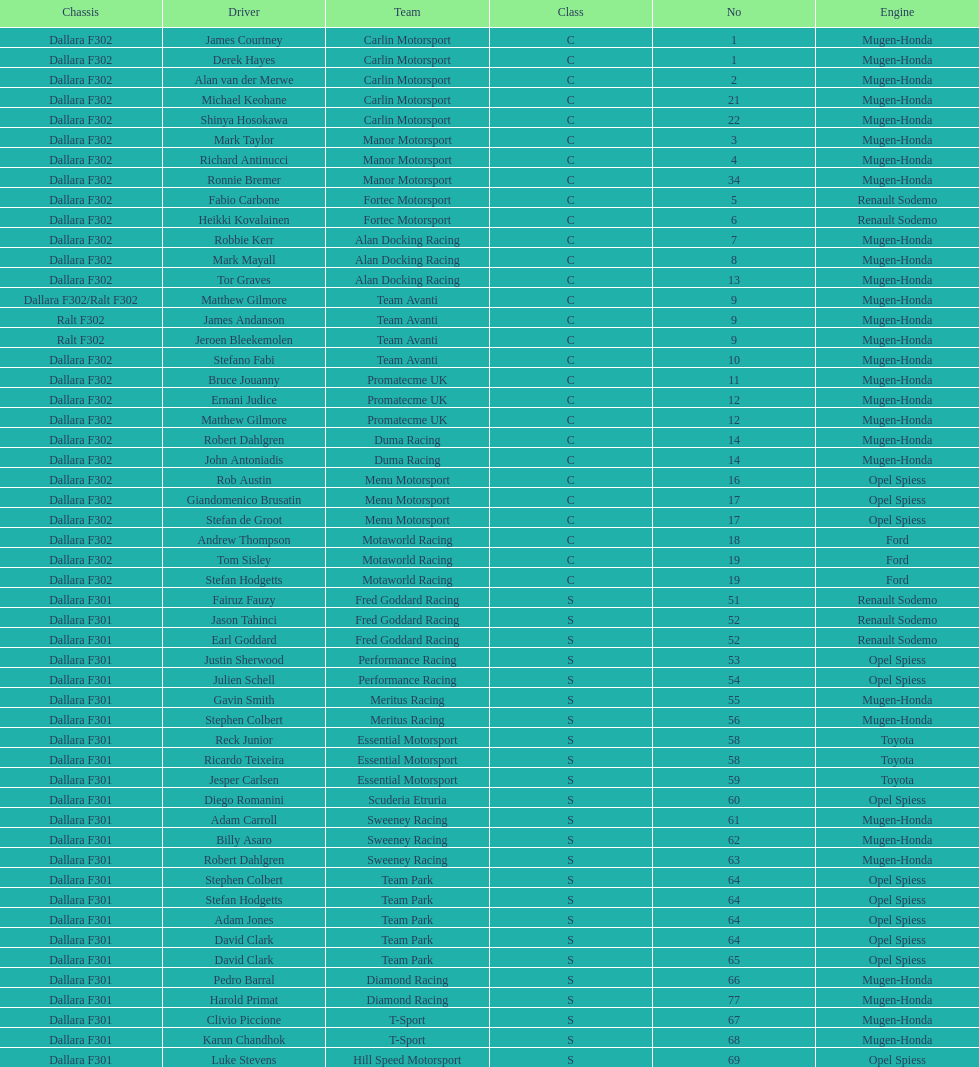How many teams had at least two drivers this season? 17. Give me the full table as a dictionary. {'header': ['Chassis', 'Driver', 'Team', 'Class', 'No', 'Engine'], 'rows': [['Dallara F302', 'James Courtney', 'Carlin Motorsport', 'C', '1', 'Mugen-Honda'], ['Dallara F302', 'Derek Hayes', 'Carlin Motorsport', 'C', '1', 'Mugen-Honda'], ['Dallara F302', 'Alan van der Merwe', 'Carlin Motorsport', 'C', '2', 'Mugen-Honda'], ['Dallara F302', 'Michael Keohane', 'Carlin Motorsport', 'C', '21', 'Mugen-Honda'], ['Dallara F302', 'Shinya Hosokawa', 'Carlin Motorsport', 'C', '22', 'Mugen-Honda'], ['Dallara F302', 'Mark Taylor', 'Manor Motorsport', 'C', '3', 'Mugen-Honda'], ['Dallara F302', 'Richard Antinucci', 'Manor Motorsport', 'C', '4', 'Mugen-Honda'], ['Dallara F302', 'Ronnie Bremer', 'Manor Motorsport', 'C', '34', 'Mugen-Honda'], ['Dallara F302', 'Fabio Carbone', 'Fortec Motorsport', 'C', '5', 'Renault Sodemo'], ['Dallara F302', 'Heikki Kovalainen', 'Fortec Motorsport', 'C', '6', 'Renault Sodemo'], ['Dallara F302', 'Robbie Kerr', 'Alan Docking Racing', 'C', '7', 'Mugen-Honda'], ['Dallara F302', 'Mark Mayall', 'Alan Docking Racing', 'C', '8', 'Mugen-Honda'], ['Dallara F302', 'Tor Graves', 'Alan Docking Racing', 'C', '13', 'Mugen-Honda'], ['Dallara F302/Ralt F302', 'Matthew Gilmore', 'Team Avanti', 'C', '9', 'Mugen-Honda'], ['Ralt F302', 'James Andanson', 'Team Avanti', 'C', '9', 'Mugen-Honda'], ['Ralt F302', 'Jeroen Bleekemolen', 'Team Avanti', 'C', '9', 'Mugen-Honda'], ['Dallara F302', 'Stefano Fabi', 'Team Avanti', 'C', '10', 'Mugen-Honda'], ['Dallara F302', 'Bruce Jouanny', 'Promatecme UK', 'C', '11', 'Mugen-Honda'], ['Dallara F302', 'Ernani Judice', 'Promatecme UK', 'C', '12', 'Mugen-Honda'], ['Dallara F302', 'Matthew Gilmore', 'Promatecme UK', 'C', '12', 'Mugen-Honda'], ['Dallara F302', 'Robert Dahlgren', 'Duma Racing', 'C', '14', 'Mugen-Honda'], ['Dallara F302', 'John Antoniadis', 'Duma Racing', 'C', '14', 'Mugen-Honda'], ['Dallara F302', 'Rob Austin', 'Menu Motorsport', 'C', '16', 'Opel Spiess'], ['Dallara F302', 'Giandomenico Brusatin', 'Menu Motorsport', 'C', '17', 'Opel Spiess'], ['Dallara F302', 'Stefan de Groot', 'Menu Motorsport', 'C', '17', 'Opel Spiess'], ['Dallara F302', 'Andrew Thompson', 'Motaworld Racing', 'C', '18', 'Ford'], ['Dallara F302', 'Tom Sisley', 'Motaworld Racing', 'C', '19', 'Ford'], ['Dallara F302', 'Stefan Hodgetts', 'Motaworld Racing', 'C', '19', 'Ford'], ['Dallara F301', 'Fairuz Fauzy', 'Fred Goddard Racing', 'S', '51', 'Renault Sodemo'], ['Dallara F301', 'Jason Tahinci', 'Fred Goddard Racing', 'S', '52', 'Renault Sodemo'], ['Dallara F301', 'Earl Goddard', 'Fred Goddard Racing', 'S', '52', 'Renault Sodemo'], ['Dallara F301', 'Justin Sherwood', 'Performance Racing', 'S', '53', 'Opel Spiess'], ['Dallara F301', 'Julien Schell', 'Performance Racing', 'S', '54', 'Opel Spiess'], ['Dallara F301', 'Gavin Smith', 'Meritus Racing', 'S', '55', 'Mugen-Honda'], ['Dallara F301', 'Stephen Colbert', 'Meritus Racing', 'S', '56', 'Mugen-Honda'], ['Dallara F301', 'Reck Junior', 'Essential Motorsport', 'S', '58', 'Toyota'], ['Dallara F301', 'Ricardo Teixeira', 'Essential Motorsport', 'S', '58', 'Toyota'], ['Dallara F301', 'Jesper Carlsen', 'Essential Motorsport', 'S', '59', 'Toyota'], ['Dallara F301', 'Diego Romanini', 'Scuderia Etruria', 'S', '60', 'Opel Spiess'], ['Dallara F301', 'Adam Carroll', 'Sweeney Racing', 'S', '61', 'Mugen-Honda'], ['Dallara F301', 'Billy Asaro', 'Sweeney Racing', 'S', '62', 'Mugen-Honda'], ['Dallara F301', 'Robert Dahlgren', 'Sweeney Racing', 'S', '63', 'Mugen-Honda'], ['Dallara F301', 'Stephen Colbert', 'Team Park', 'S', '64', 'Opel Spiess'], ['Dallara F301', 'Stefan Hodgetts', 'Team Park', 'S', '64', 'Opel Spiess'], ['Dallara F301', 'Adam Jones', 'Team Park', 'S', '64', 'Opel Spiess'], ['Dallara F301', 'David Clark', 'Team Park', 'S', '64', 'Opel Spiess'], ['Dallara F301', 'David Clark', 'Team Park', 'S', '65', 'Opel Spiess'], ['Dallara F301', 'Pedro Barral', 'Diamond Racing', 'S', '66', 'Mugen-Honda'], ['Dallara F301', 'Harold Primat', 'Diamond Racing', 'S', '77', 'Mugen-Honda'], ['Dallara F301', 'Clivio Piccione', 'T-Sport', 'S', '67', 'Mugen-Honda'], ['Dallara F301', 'Karun Chandhok', 'T-Sport', 'S', '68', 'Mugen-Honda'], ['Dallara F301', 'Luke Stevens', 'Hill Speed Motorsport', 'S', '69', 'Opel Spiess']]} 